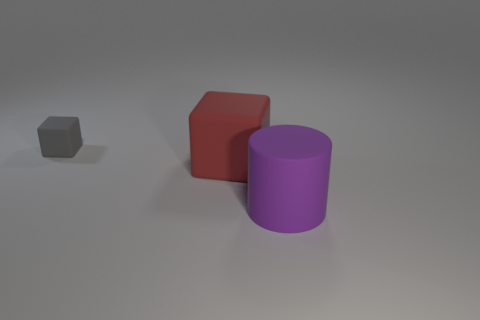What number of large objects are either cubes or rubber objects?
Offer a terse response. 2. Are there any small gray rubber things?
Offer a very short reply. Yes. There is a purple thing that is made of the same material as the tiny gray cube; what size is it?
Give a very brief answer. Large. How many other things are made of the same material as the tiny cube?
Give a very brief answer. 2. What number of matte objects are to the left of the purple cylinder and to the right of the small gray cube?
Your answer should be compact. 1. What is the color of the big cube?
Your answer should be very brief. Red. There is a purple thing that is to the right of the big thing to the left of the rubber cylinder; what shape is it?
Give a very brief answer. Cylinder. The tiny gray object that is the same material as the large cylinder is what shape?
Give a very brief answer. Cube. How many other objects are there of the same shape as the small rubber thing?
Your response must be concise. 1. There is a matte object that is in front of the red block; is its size the same as the tiny gray matte block?
Offer a very short reply. No. 